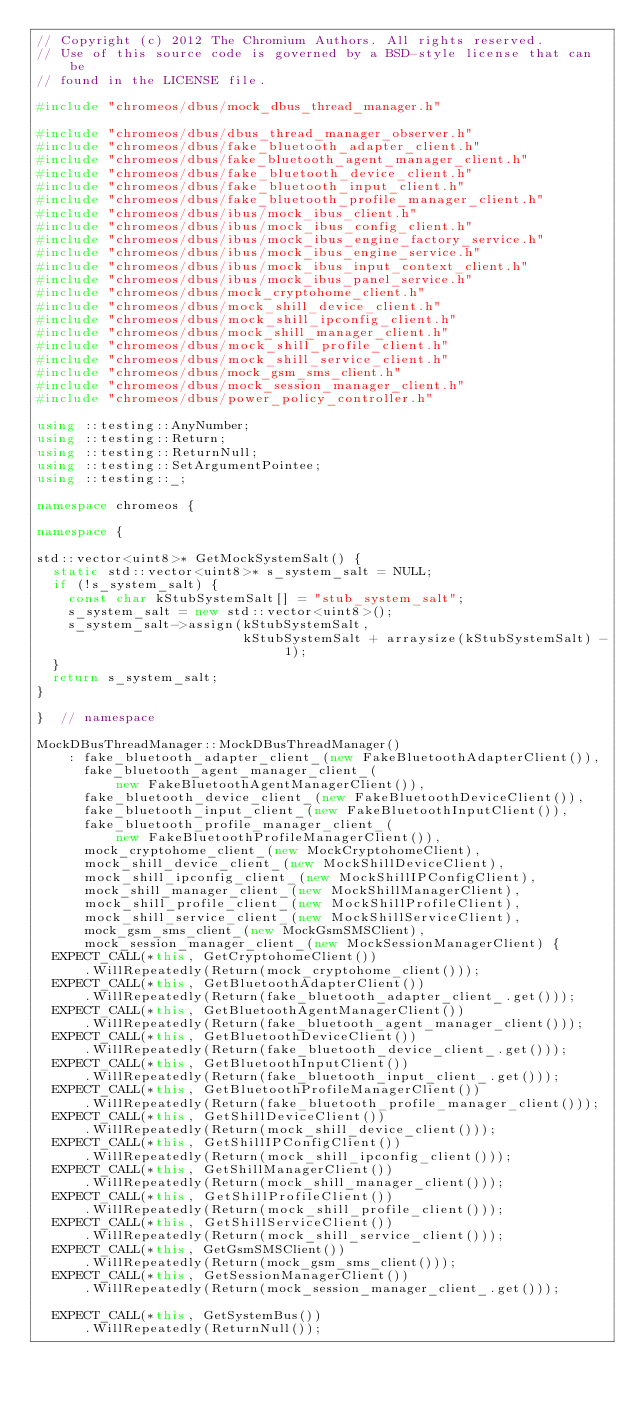<code> <loc_0><loc_0><loc_500><loc_500><_C++_>// Copyright (c) 2012 The Chromium Authors. All rights reserved.
// Use of this source code is governed by a BSD-style license that can be
// found in the LICENSE file.

#include "chromeos/dbus/mock_dbus_thread_manager.h"

#include "chromeos/dbus/dbus_thread_manager_observer.h"
#include "chromeos/dbus/fake_bluetooth_adapter_client.h"
#include "chromeos/dbus/fake_bluetooth_agent_manager_client.h"
#include "chromeos/dbus/fake_bluetooth_device_client.h"
#include "chromeos/dbus/fake_bluetooth_input_client.h"
#include "chromeos/dbus/fake_bluetooth_profile_manager_client.h"
#include "chromeos/dbus/ibus/mock_ibus_client.h"
#include "chromeos/dbus/ibus/mock_ibus_config_client.h"
#include "chromeos/dbus/ibus/mock_ibus_engine_factory_service.h"
#include "chromeos/dbus/ibus/mock_ibus_engine_service.h"
#include "chromeos/dbus/ibus/mock_ibus_input_context_client.h"
#include "chromeos/dbus/ibus/mock_ibus_panel_service.h"
#include "chromeos/dbus/mock_cryptohome_client.h"
#include "chromeos/dbus/mock_shill_device_client.h"
#include "chromeos/dbus/mock_shill_ipconfig_client.h"
#include "chromeos/dbus/mock_shill_manager_client.h"
#include "chromeos/dbus/mock_shill_profile_client.h"
#include "chromeos/dbus/mock_shill_service_client.h"
#include "chromeos/dbus/mock_gsm_sms_client.h"
#include "chromeos/dbus/mock_session_manager_client.h"
#include "chromeos/dbus/power_policy_controller.h"

using ::testing::AnyNumber;
using ::testing::Return;
using ::testing::ReturnNull;
using ::testing::SetArgumentPointee;
using ::testing::_;

namespace chromeos {

namespace {

std::vector<uint8>* GetMockSystemSalt() {
  static std::vector<uint8>* s_system_salt = NULL;
  if (!s_system_salt) {
    const char kStubSystemSalt[] = "stub_system_salt";
    s_system_salt = new std::vector<uint8>();
    s_system_salt->assign(kStubSystemSalt,
                          kStubSystemSalt + arraysize(kStubSystemSalt) - 1);
  }
  return s_system_salt;
}

}  // namespace

MockDBusThreadManager::MockDBusThreadManager()
    : fake_bluetooth_adapter_client_(new FakeBluetoothAdapterClient()),
      fake_bluetooth_agent_manager_client_(
          new FakeBluetoothAgentManagerClient()),
      fake_bluetooth_device_client_(new FakeBluetoothDeviceClient()),
      fake_bluetooth_input_client_(new FakeBluetoothInputClient()),
      fake_bluetooth_profile_manager_client_(
          new FakeBluetoothProfileManagerClient()),
      mock_cryptohome_client_(new MockCryptohomeClient),
      mock_shill_device_client_(new MockShillDeviceClient),
      mock_shill_ipconfig_client_(new MockShillIPConfigClient),
      mock_shill_manager_client_(new MockShillManagerClient),
      mock_shill_profile_client_(new MockShillProfileClient),
      mock_shill_service_client_(new MockShillServiceClient),
      mock_gsm_sms_client_(new MockGsmSMSClient),
      mock_session_manager_client_(new MockSessionManagerClient) {
  EXPECT_CALL(*this, GetCryptohomeClient())
      .WillRepeatedly(Return(mock_cryptohome_client()));
  EXPECT_CALL(*this, GetBluetoothAdapterClient())
      .WillRepeatedly(Return(fake_bluetooth_adapter_client_.get()));
  EXPECT_CALL(*this, GetBluetoothAgentManagerClient())
      .WillRepeatedly(Return(fake_bluetooth_agent_manager_client()));
  EXPECT_CALL(*this, GetBluetoothDeviceClient())
      .WillRepeatedly(Return(fake_bluetooth_device_client_.get()));
  EXPECT_CALL(*this, GetBluetoothInputClient())
      .WillRepeatedly(Return(fake_bluetooth_input_client_.get()));
  EXPECT_CALL(*this, GetBluetoothProfileManagerClient())
      .WillRepeatedly(Return(fake_bluetooth_profile_manager_client()));
  EXPECT_CALL(*this, GetShillDeviceClient())
      .WillRepeatedly(Return(mock_shill_device_client()));
  EXPECT_CALL(*this, GetShillIPConfigClient())
      .WillRepeatedly(Return(mock_shill_ipconfig_client()));
  EXPECT_CALL(*this, GetShillManagerClient())
      .WillRepeatedly(Return(mock_shill_manager_client()));
  EXPECT_CALL(*this, GetShillProfileClient())
      .WillRepeatedly(Return(mock_shill_profile_client()));
  EXPECT_CALL(*this, GetShillServiceClient())
      .WillRepeatedly(Return(mock_shill_service_client()));
  EXPECT_CALL(*this, GetGsmSMSClient())
      .WillRepeatedly(Return(mock_gsm_sms_client()));
  EXPECT_CALL(*this, GetSessionManagerClient())
      .WillRepeatedly(Return(mock_session_manager_client_.get()));

  EXPECT_CALL(*this, GetSystemBus())
      .WillRepeatedly(ReturnNull());</code> 